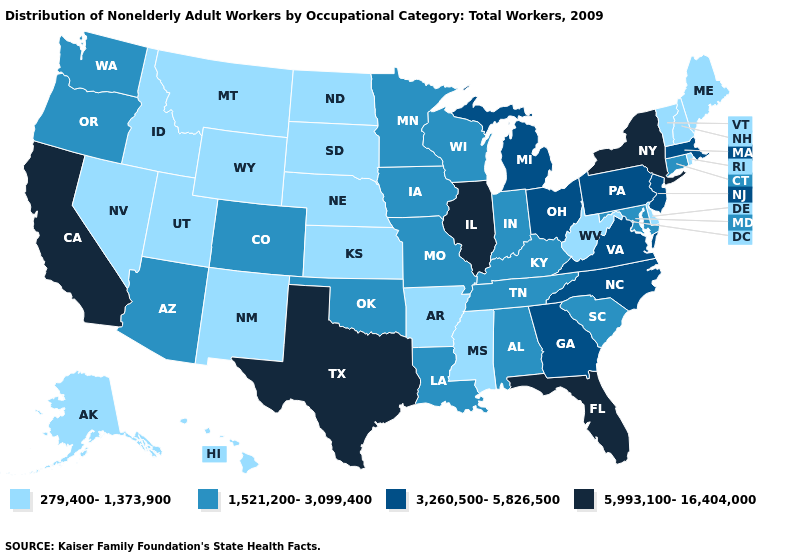Among the states that border Missouri , does Kentucky have the highest value?
Short answer required. No. Name the states that have a value in the range 1,521,200-3,099,400?
Short answer required. Alabama, Arizona, Colorado, Connecticut, Indiana, Iowa, Kentucky, Louisiana, Maryland, Minnesota, Missouri, Oklahoma, Oregon, South Carolina, Tennessee, Washington, Wisconsin. What is the value of Wyoming?
Be succinct. 279,400-1,373,900. What is the value of Wyoming?
Quick response, please. 279,400-1,373,900. Is the legend a continuous bar?
Write a very short answer. No. Does the first symbol in the legend represent the smallest category?
Keep it brief. Yes. What is the value of Maryland?
Quick response, please. 1,521,200-3,099,400. Is the legend a continuous bar?
Give a very brief answer. No. Which states have the lowest value in the MidWest?
Write a very short answer. Kansas, Nebraska, North Dakota, South Dakota. Does Connecticut have a higher value than New Hampshire?
Answer briefly. Yes. What is the lowest value in the USA?
Give a very brief answer. 279,400-1,373,900. Does Oregon have the same value as Arizona?
Be succinct. Yes. What is the value of Oklahoma?
Answer briefly. 1,521,200-3,099,400. Which states have the highest value in the USA?
Give a very brief answer. California, Florida, Illinois, New York, Texas. Name the states that have a value in the range 5,993,100-16,404,000?
Write a very short answer. California, Florida, Illinois, New York, Texas. 